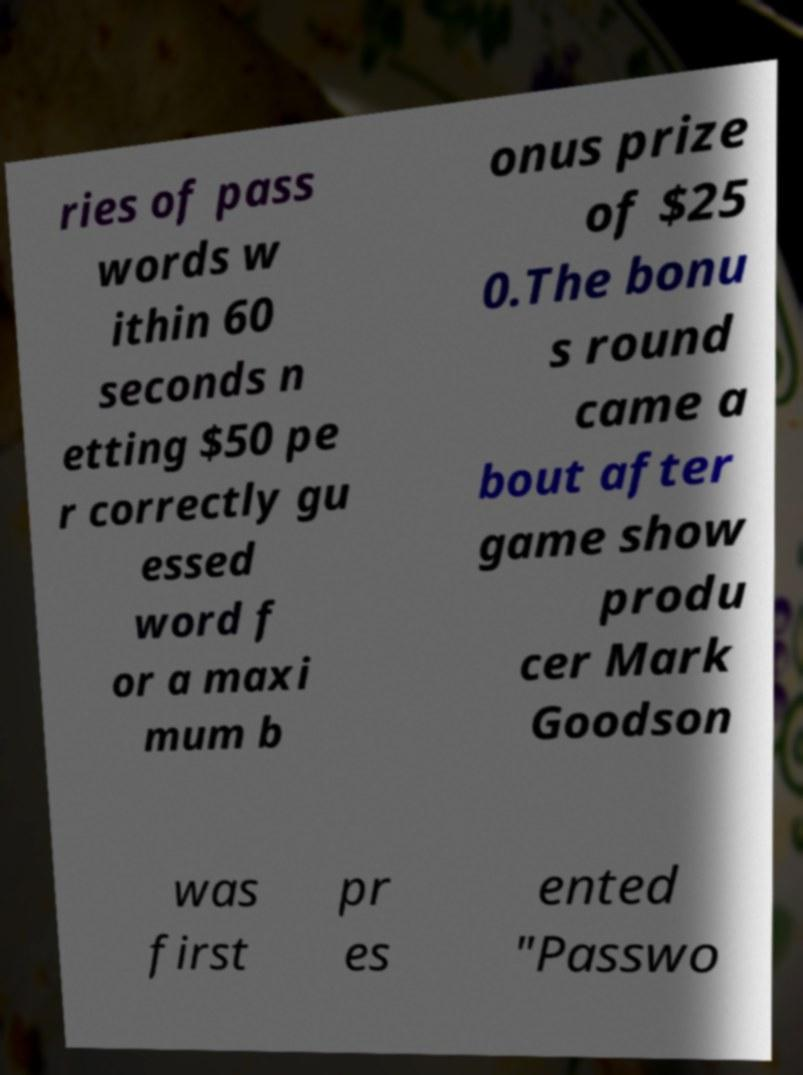Can you read and provide the text displayed in the image?This photo seems to have some interesting text. Can you extract and type it out for me? ries of pass words w ithin 60 seconds n etting $50 pe r correctly gu essed word f or a maxi mum b onus prize of $25 0.The bonu s round came a bout after game show produ cer Mark Goodson was first pr es ented "Passwo 